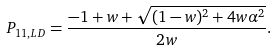<formula> <loc_0><loc_0><loc_500><loc_500>P _ { 1 1 , L D } = \frac { - 1 + w + \sqrt { ( 1 - w ) ^ { 2 } + 4 w \alpha ^ { 2 } } } { 2 w } .</formula> 